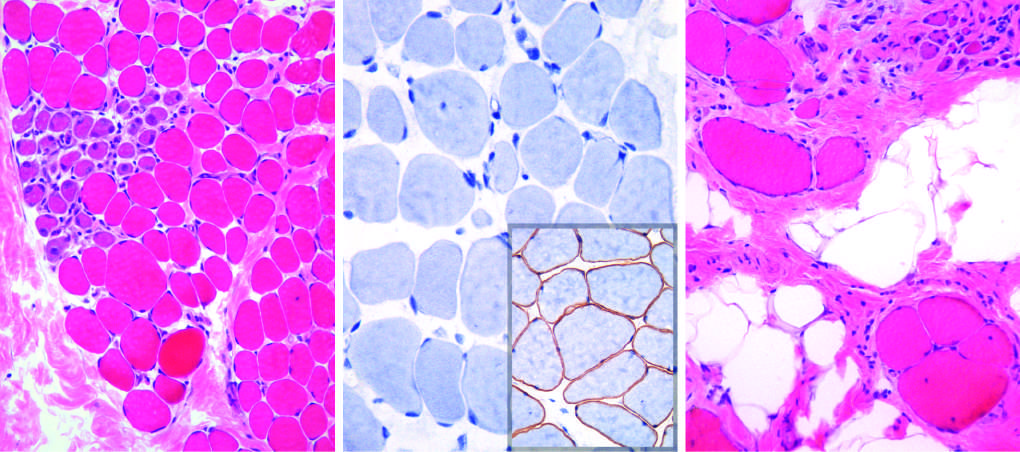s there a cluster of basophilic regenerating myofibers and slight endomysial fibrosis, seen as focal pink-staining connective tissue between myofibers?
Answer the question using a single word or phrase. Yes 